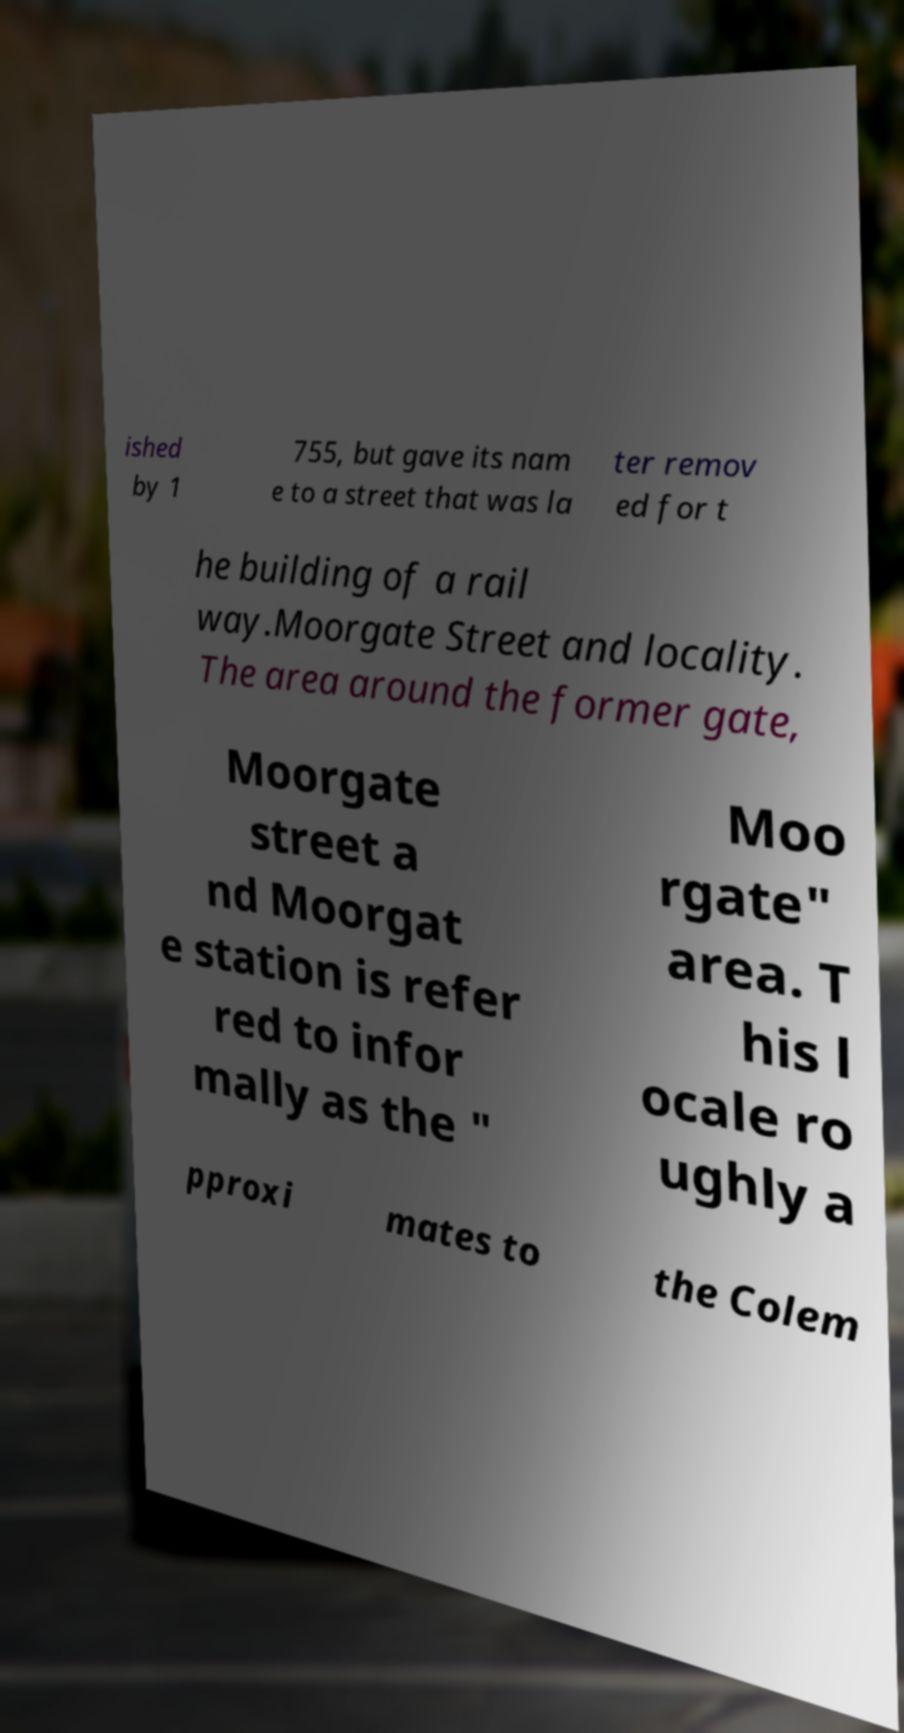For documentation purposes, I need the text within this image transcribed. Could you provide that? ished by 1 755, but gave its nam e to a street that was la ter remov ed for t he building of a rail way.Moorgate Street and locality. The area around the former gate, Moorgate street a nd Moorgat e station is refer red to infor mally as the " Moo rgate" area. T his l ocale ro ughly a pproxi mates to the Colem 